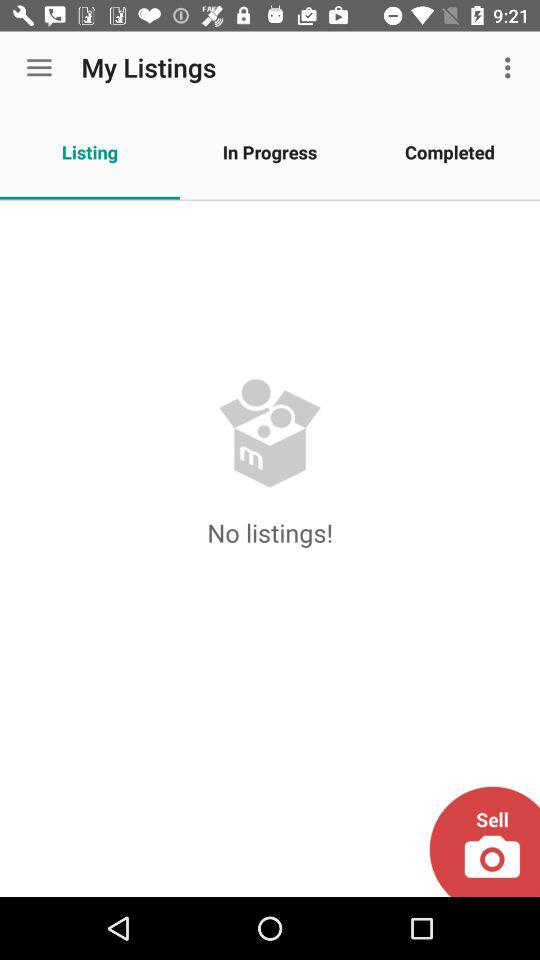Are there any listings? There is no listing. 